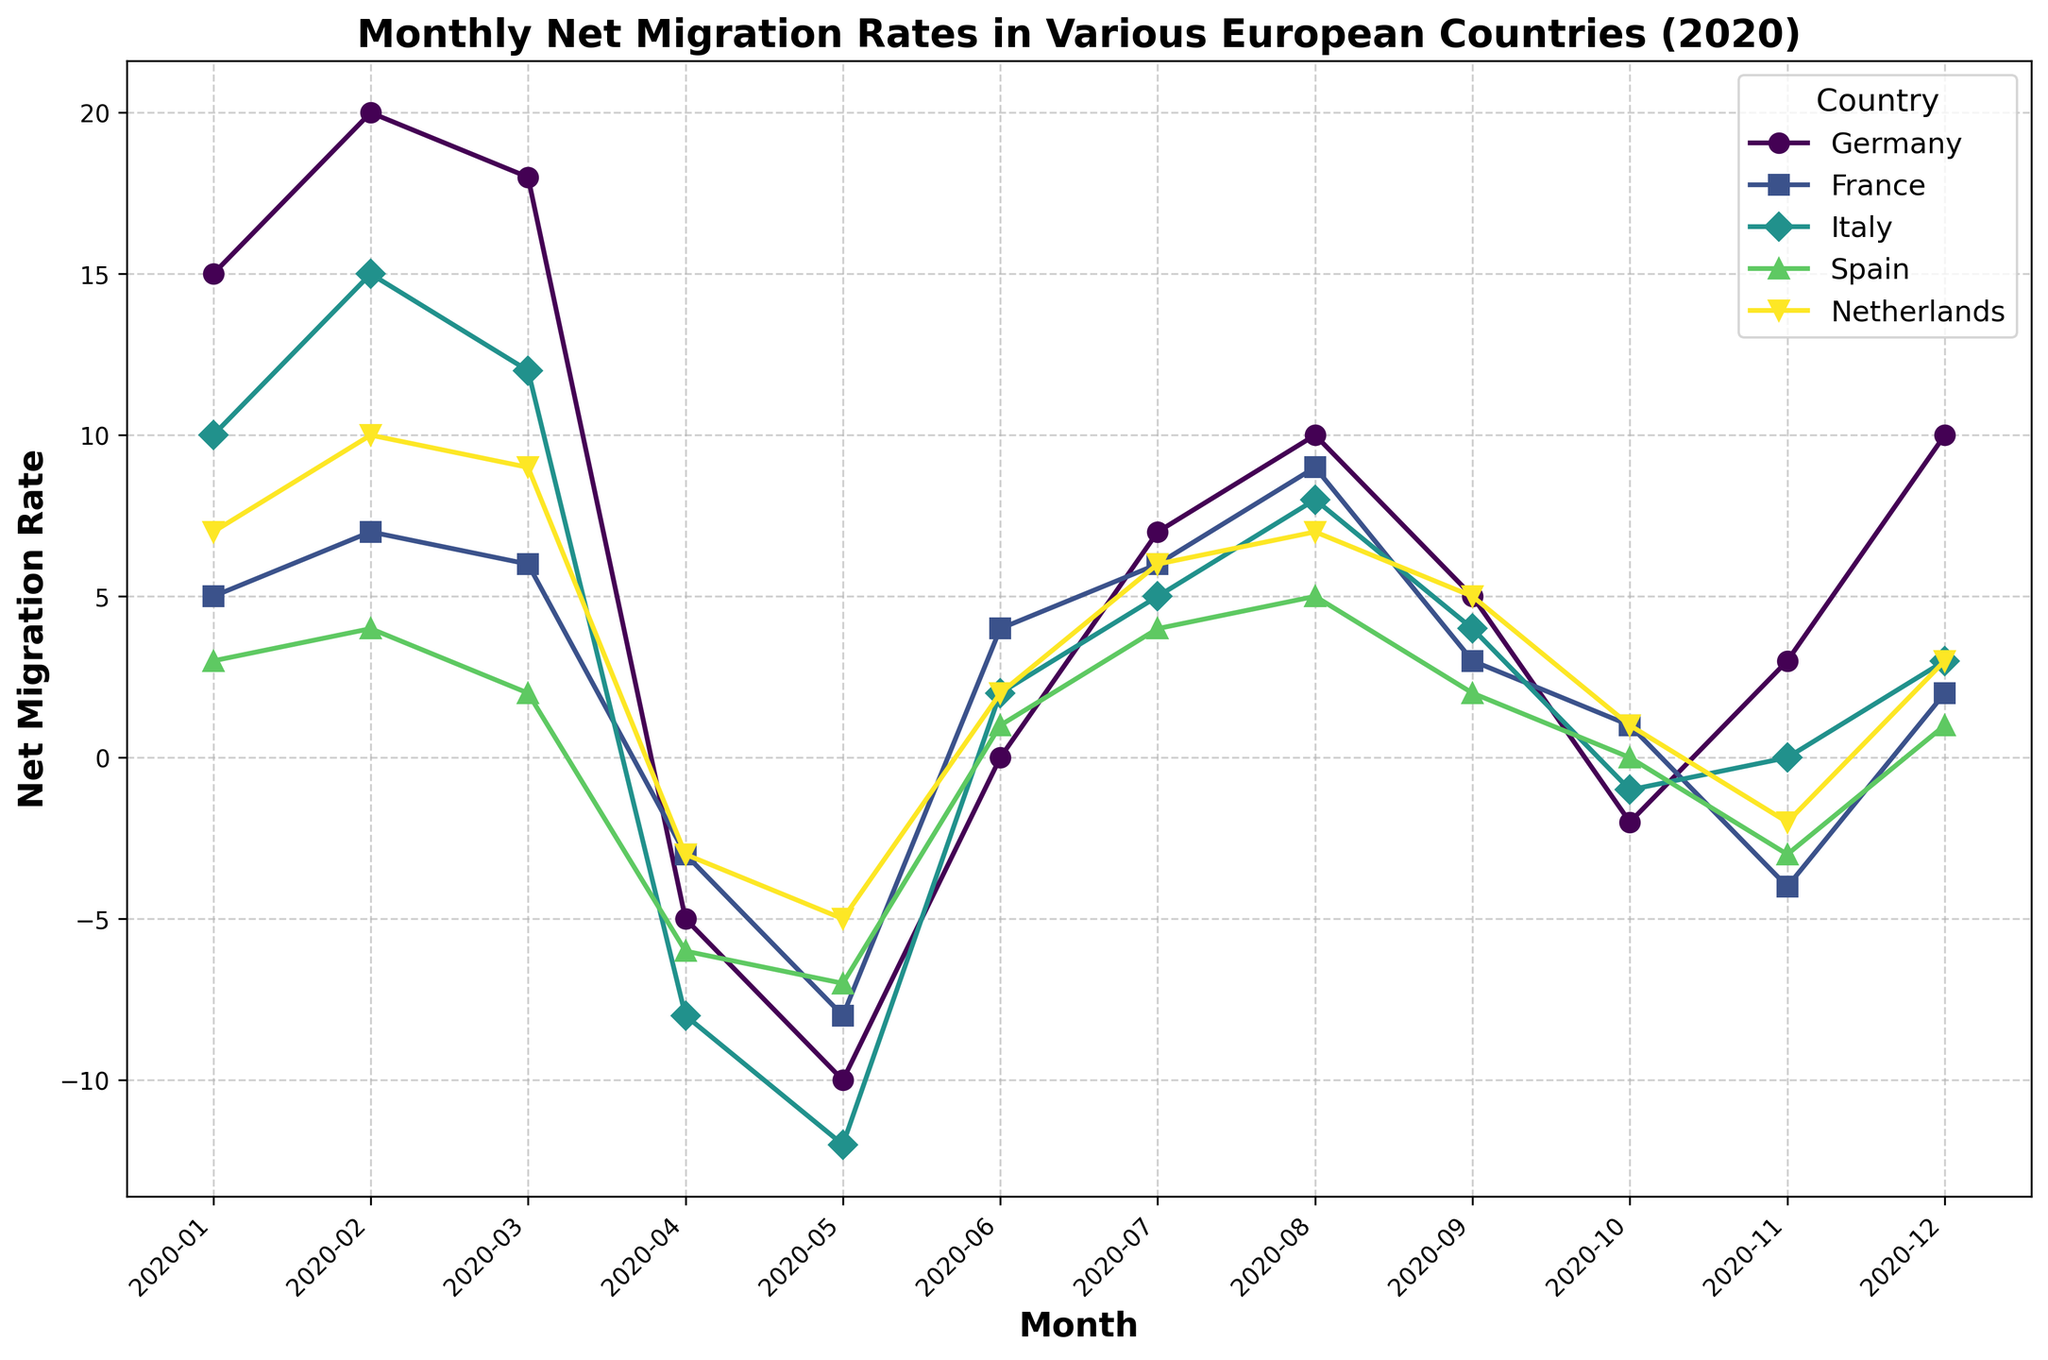What country showed the most drastic change in net migration rate in a single month? Germany showed a drop from 20 in February to -5 in April, a change of 25 points. This is the most drastic single-month change.
Answer: Germany Which country had the highest net migration rate at any point in 2020? The highest net migration rate observed in the chart is 20 for Germany in February 2020.
Answer: Germany From January to December, how many months did Italy have a negative net migration rate? Italy had negative net migration rates in April, May, and October, totaling 3 months.
Answer: 3 Compare the net migration rate of France and the Netherlands in April 2020. Which country had the lower rate? In April 2020, France had a net migration rate of -3, and the Netherlands had the same rate of -3. Therefore, both had the same rate.
Answer: Both the same What is the average net migration rate for Spain over the entire year 2020? Summing up Spain's net migration rates for all months: (3 + 4 + 2 + (-6) + (-7) + 1 + 4 + 5 + 2 + 0 + (-3) + 1) = 6. The average across 12 months is 6/12 = 0.5.
Answer: 0.5 In which month did Germany and Italy both have negative net migration rates? Both Germany and Italy had negative net migration rates in April 2020.
Answer: April Which country showed a consistent increase in net migration rate from May to August 2020? France saw a consistent increase in net migration rate from May (-8), June (4), July (6), to August (9).
Answer: France Calculate the overall net migration change for the Netherlands from January to December 2020. The overall change for the Netherlands is the difference between the net migration rate in December (3) and January (7). So, 3 - 7 = -4.
Answer: -4 Compare the net migration rates of Germany and Spain in November 2020. Which country had a higher rate? In November 2020, Germany had a net migration rate of 3, while Spain had a net migration rate of -3. Germany had a higher rate.
Answer: Germany 